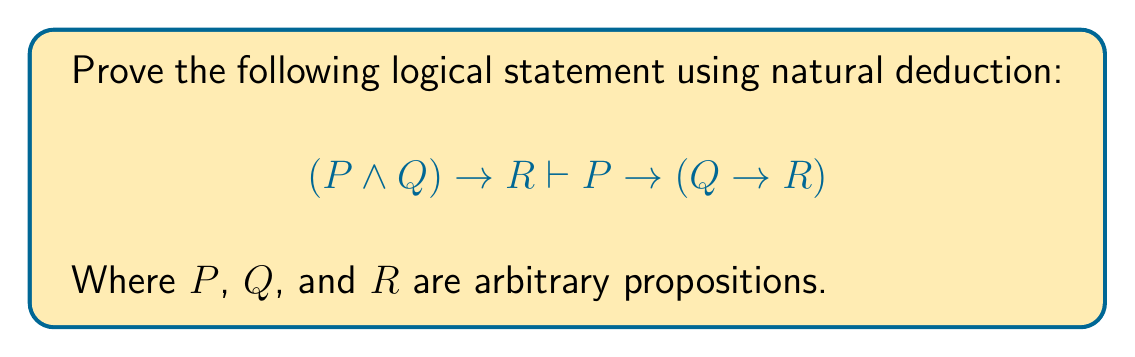Solve this math problem. To prove this logical statement using natural deduction, we'll follow these steps:

1. Start with the given premise: $(P \land Q) \to R$
2. Assume $P$ (for conditional proof)
3. Assume $Q$ (for nested conditional proof)
4. Use conjunction introduction to derive $P \land Q$
5. Apply modus ponens with the premise and $P \land Q$
6. Conclude $R$
7. Discharge the assumption $Q$ to derive $Q \to R$
8. Discharge the assumption $P$ to derive $P \to (Q \to R)$

Detailed proof:

1. $(P \land Q) \to R$ (premise)
2. $P$ (assumption for conditional proof)
3. $Q$ (assumption for nested conditional proof)
4. $P \land Q$ (conjunction introduction, 2, 3)
5. $R$ (modus ponens, 1, 4)
6. $Q \to R$ (conditional proof, discharge 3)
7. $P \to (Q \to R)$ (conditional proof, discharge 2)

This proof demonstrates that if $(P \land Q) \to R$ is true, then $P \to (Q \to R)$ must also be true, regardless of the specific content of propositions $P$, $Q$, and $R$.
Answer: The logical statement $(P \land Q) \to R \vdash P \to (Q \to R)$ is proven valid using natural deduction. 